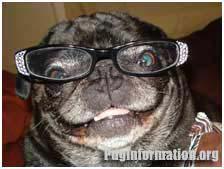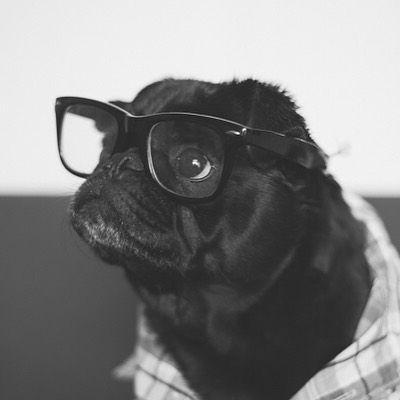The first image is the image on the left, the second image is the image on the right. Assess this claim about the two images: "The pug in the right image faces the camera head-on and wears glasses with round lenses.". Correct or not? Answer yes or no. No. 